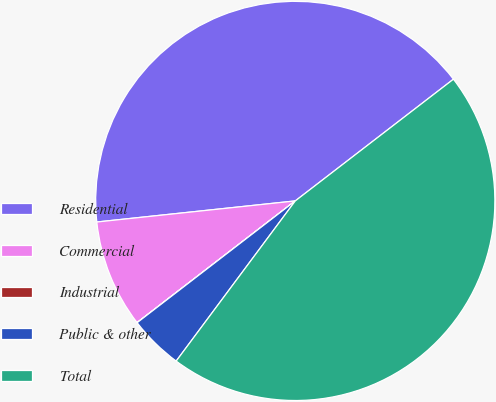Convert chart. <chart><loc_0><loc_0><loc_500><loc_500><pie_chart><fcel>Residential<fcel>Commercial<fcel>Industrial<fcel>Public & other<fcel>Total<nl><fcel>41.25%<fcel>8.75%<fcel>0.01%<fcel>4.38%<fcel>45.62%<nl></chart> 